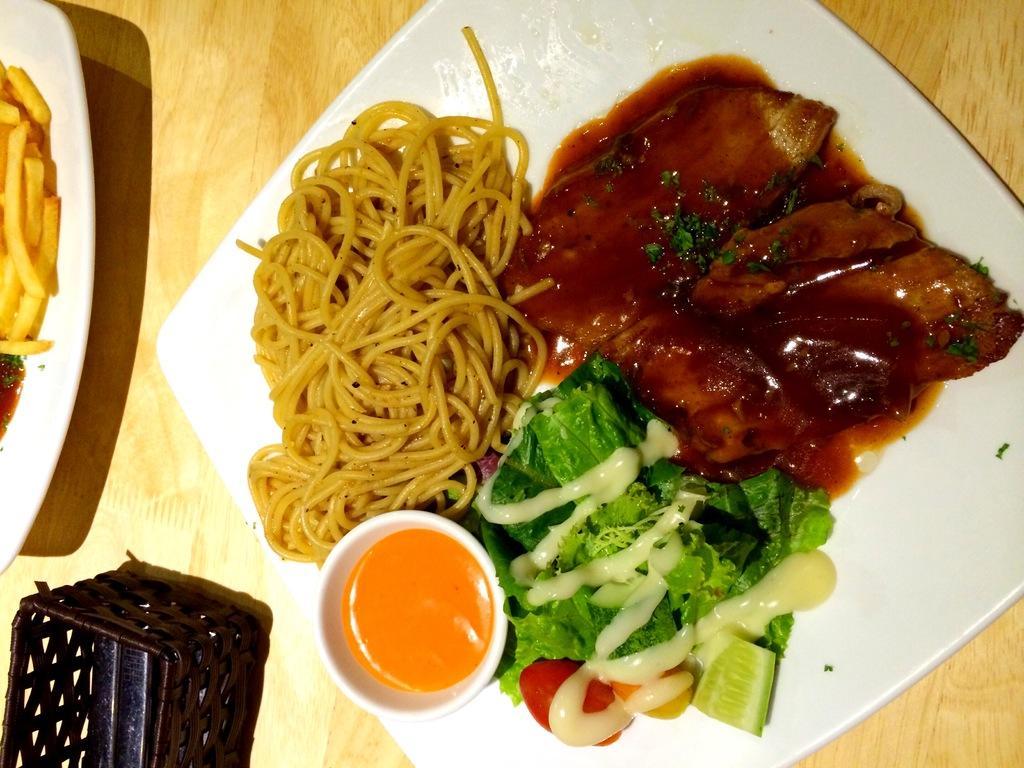Can you describe this image briefly? On the left side, there are food items arranged in a white colored plate and there is a brown colored object. On the right side, there are food items arranged in a white colored plate which is on a wooden surface. 